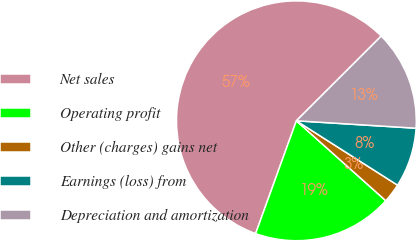Convert chart. <chart><loc_0><loc_0><loc_500><loc_500><pie_chart><fcel>Net sales<fcel>Operating profit<fcel>Other (charges) gains net<fcel>Earnings (loss) from<fcel>Depreciation and amortization<nl><fcel>56.99%<fcel>18.91%<fcel>2.59%<fcel>8.03%<fcel>13.47%<nl></chart> 